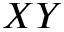<formula> <loc_0><loc_0><loc_500><loc_500>X Y</formula> 